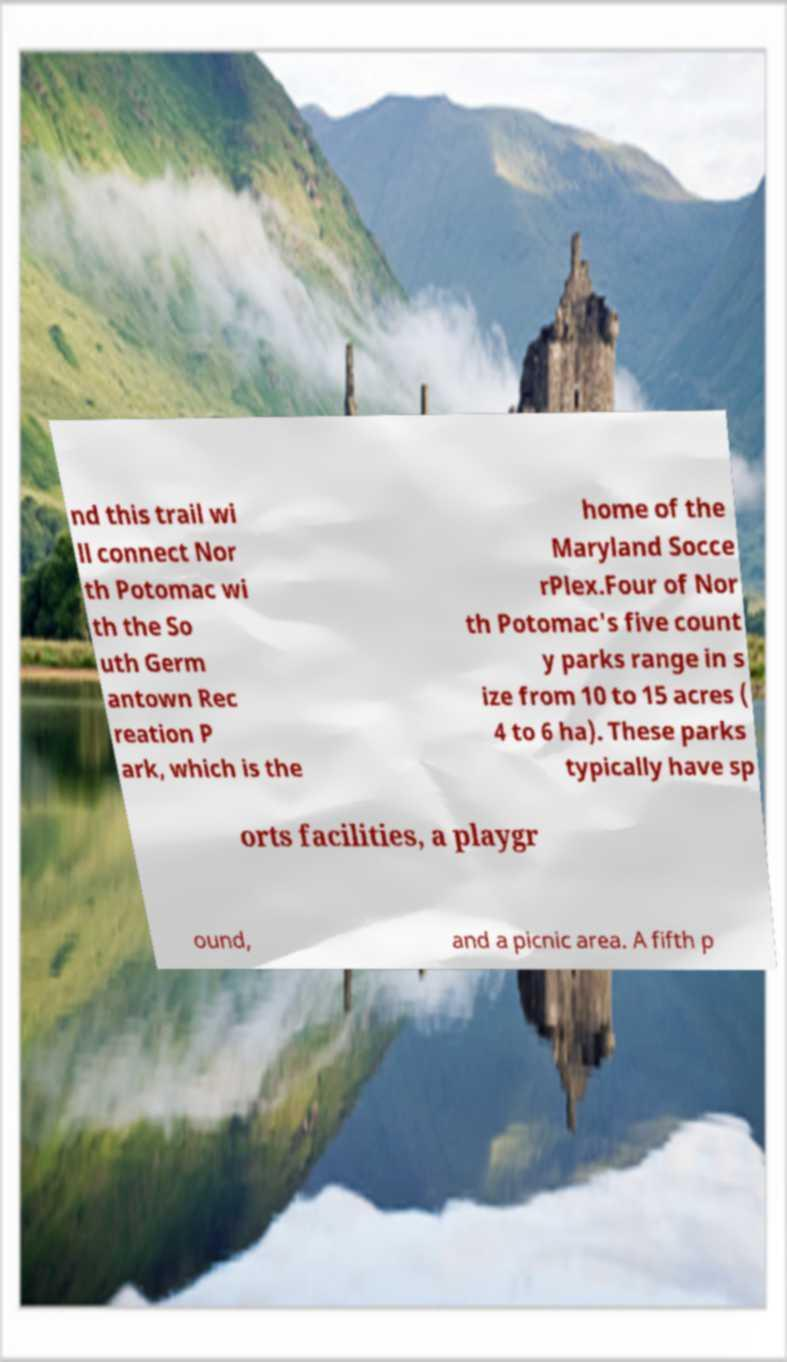Could you extract and type out the text from this image? nd this trail wi ll connect Nor th Potomac wi th the So uth Germ antown Rec reation P ark, which is the home of the Maryland Socce rPlex.Four of Nor th Potomac's five count y parks range in s ize from 10 to 15 acres ( 4 to 6 ha). These parks typically have sp orts facilities, a playgr ound, and a picnic area. A fifth p 